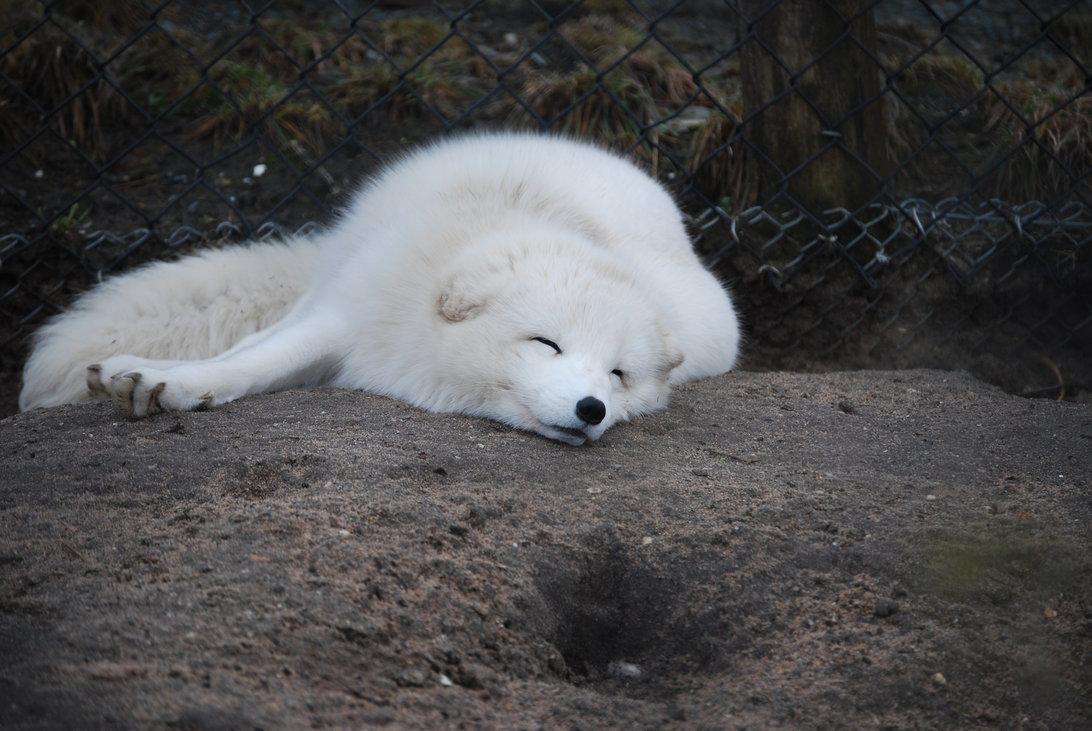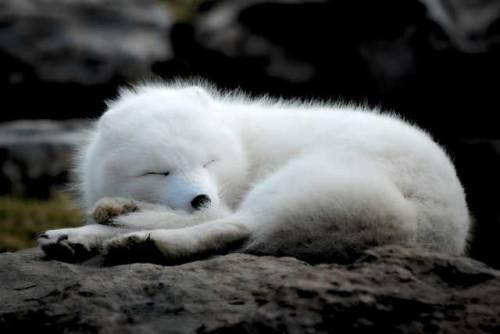The first image is the image on the left, the second image is the image on the right. Evaluate the accuracy of this statement regarding the images: "At least one white wolf has its eyes open.". Is it true? Answer yes or no. No. The first image is the image on the left, the second image is the image on the right. Analyze the images presented: Is the assertion "Each image shows a reclining white dog with fully closed eyes, and the dogs in the left and right images look similar in terms of size, coloring, breed and ear position." valid? Answer yes or no. Yes. 